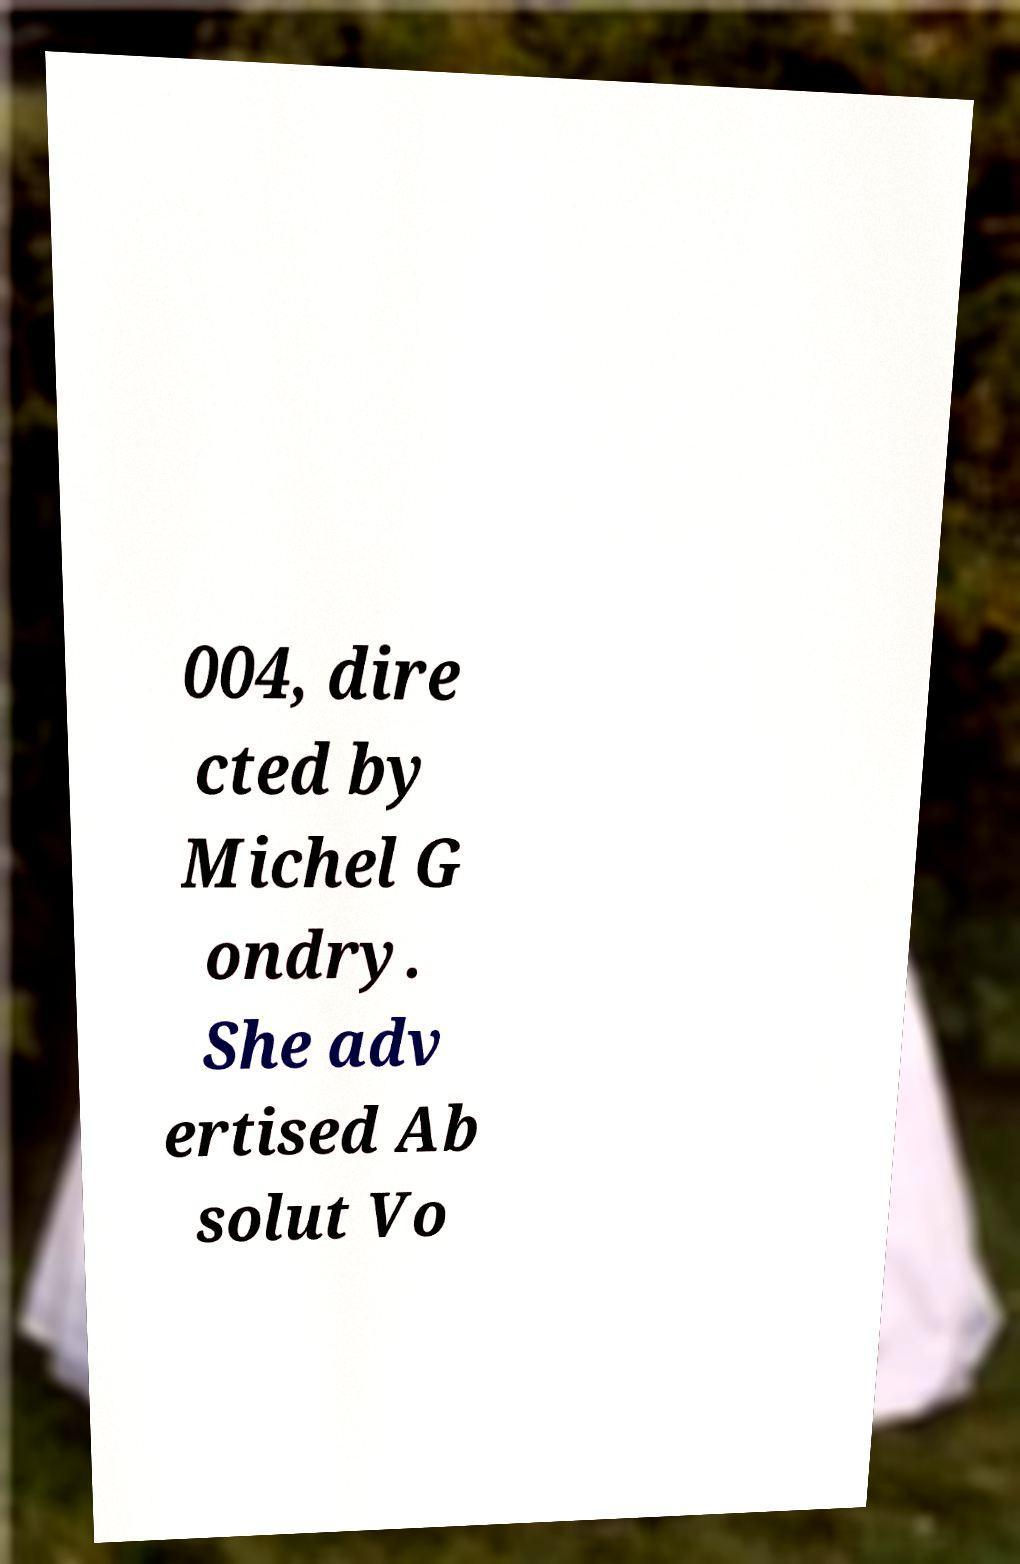I need the written content from this picture converted into text. Can you do that? 004, dire cted by Michel G ondry. She adv ertised Ab solut Vo 